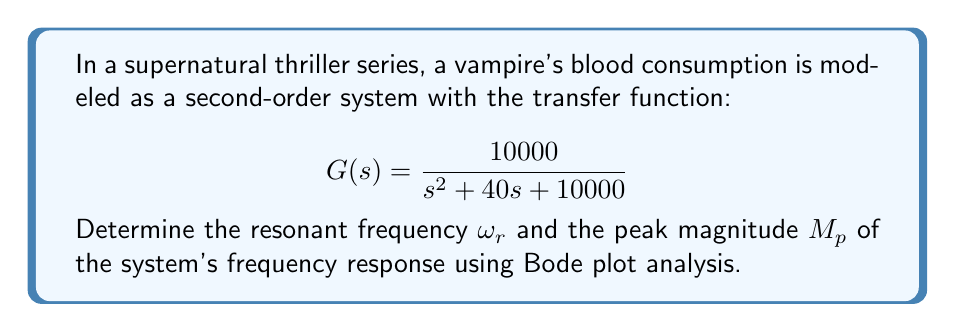Help me with this question. To analyze the frequency response using Bode plots, we need to follow these steps:

1. Identify the system's natural frequency $\omega_n$ and damping ratio $\zeta$:

The standard form of a second-order transfer function is:

$$ G(s) = \frac{\omega_n^2}{s^2 + 2\zeta\omega_n s + \omega_n^2} $$

Comparing this to our given transfer function:

$$ G(s) = \frac{10000}{s^2 + 40s + 10000} $$

We can see that $\omega_n^2 = 10000$, so $\omega_n = 100$ rad/s.

And $2\zeta\omega_n = 40$, so $\zeta = \frac{40}{2\omega_n} = \frac{40}{200} = 0.2$

2. Calculate the resonant frequency $\omega_r$:

For an underdamped system ($\zeta < 1$), the resonant frequency is given by:

$$ \omega_r = \omega_n\sqrt{1 - 2\zeta^2} $$

Substituting our values:

$$ \omega_r = 100\sqrt{1 - 2(0.2)^2} = 100\sqrt{1 - 0.08} = 100\sqrt{0.92} \approx 95.92 \text{ rad/s} $$

3. Calculate the peak magnitude $M_p$:

The peak magnitude occurs at the resonant frequency and is given by:

$$ M_p = \frac{1}{2\zeta\sqrt{1-\zeta^2}} $$

Substituting our damping ratio:

$$ M_p = \frac{1}{2(0.2)\sqrt{1-(0.2)^2}} = \frac{1}{0.4\sqrt{0.96}} \approx 2.55 $$

This means the peak magnitude is approximately 2.55 or 8.13 dB.
Answer: Resonant frequency: $\omega_r \approx 95.92 \text{ rad/s}$
Peak magnitude: $M_p \approx 2.55$ (or 8.13 dB) 